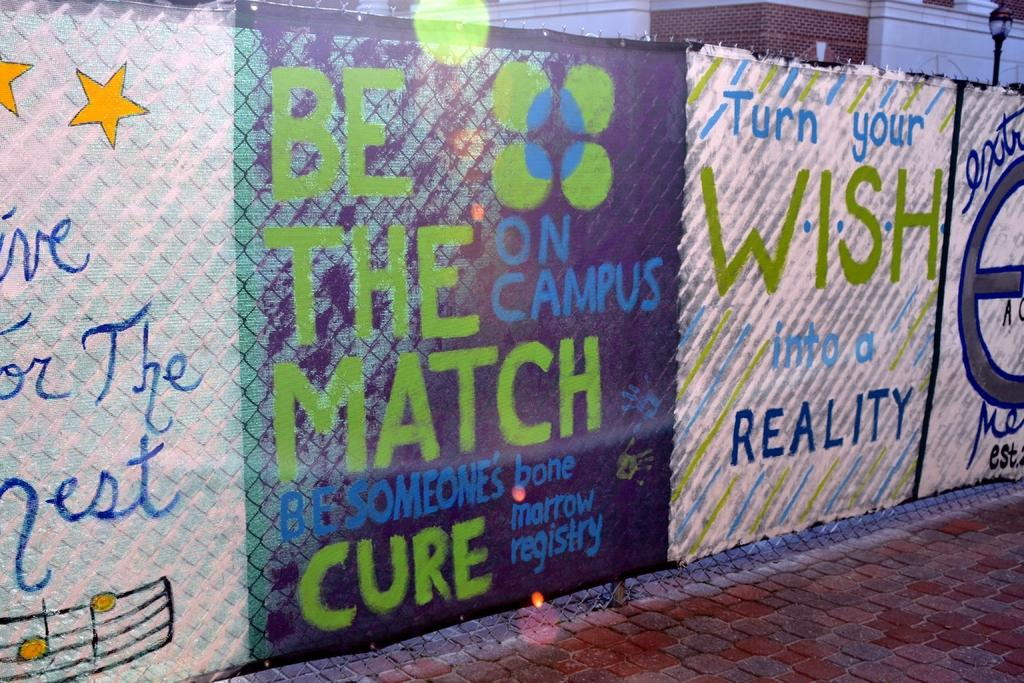<image>
Give a short and clear explanation of the subsequent image. A painted tapestry encouraging people to enter themselves into the bone marrow registry 